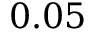<formula> <loc_0><loc_0><loc_500><loc_500>0 . 0 5</formula> 